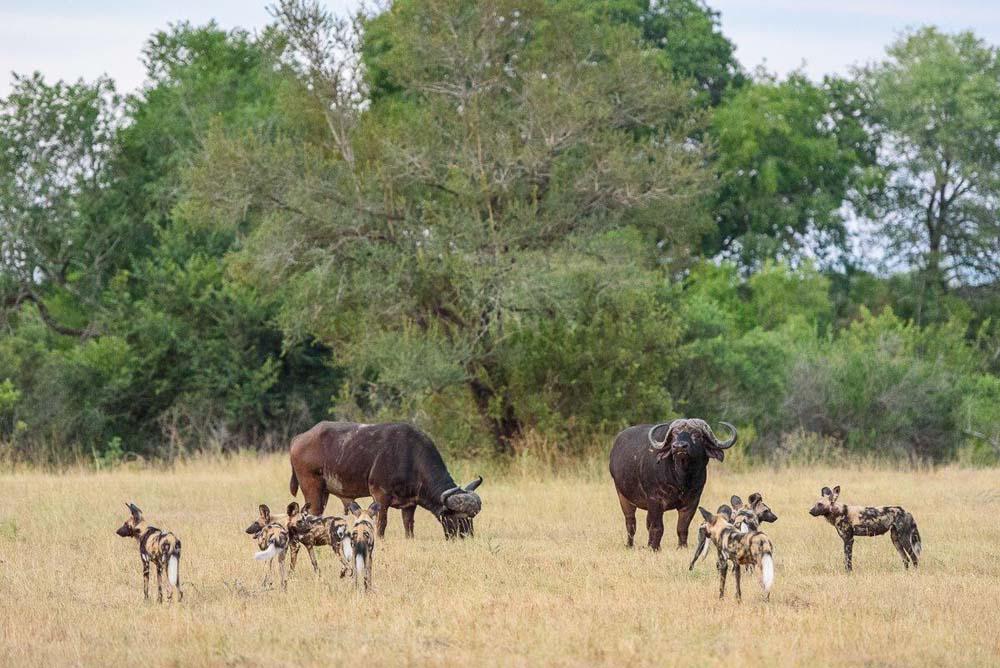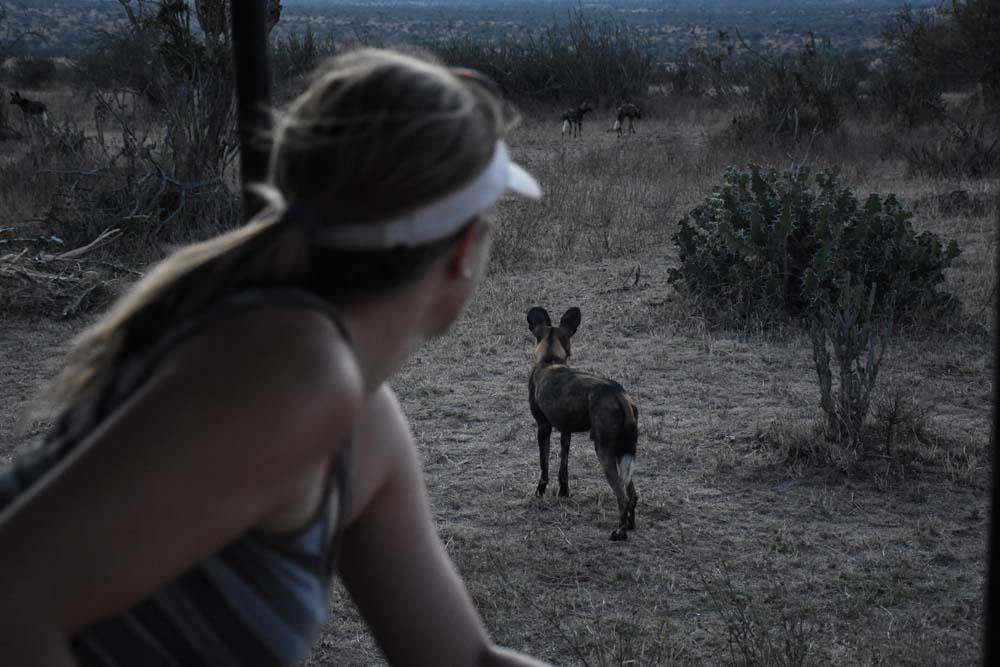The first image is the image on the left, the second image is the image on the right. Analyze the images presented: Is the assertion "In one image in the pair, the only animal that can be seen is the hyena." valid? Answer yes or no. No. The first image is the image on the left, the second image is the image on the right. Examine the images to the left and right. Is the description "The left image shows at least one rear-facing hyena standing in front of two larger standing animals with horns." accurate? Answer yes or no. Yes. 